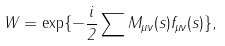<formula> <loc_0><loc_0><loc_500><loc_500>W = \exp \{ - \frac { i } { 2 } \sum M _ { \mu \nu } ( s ) f _ { \mu \nu } ( s ) \} ,</formula> 